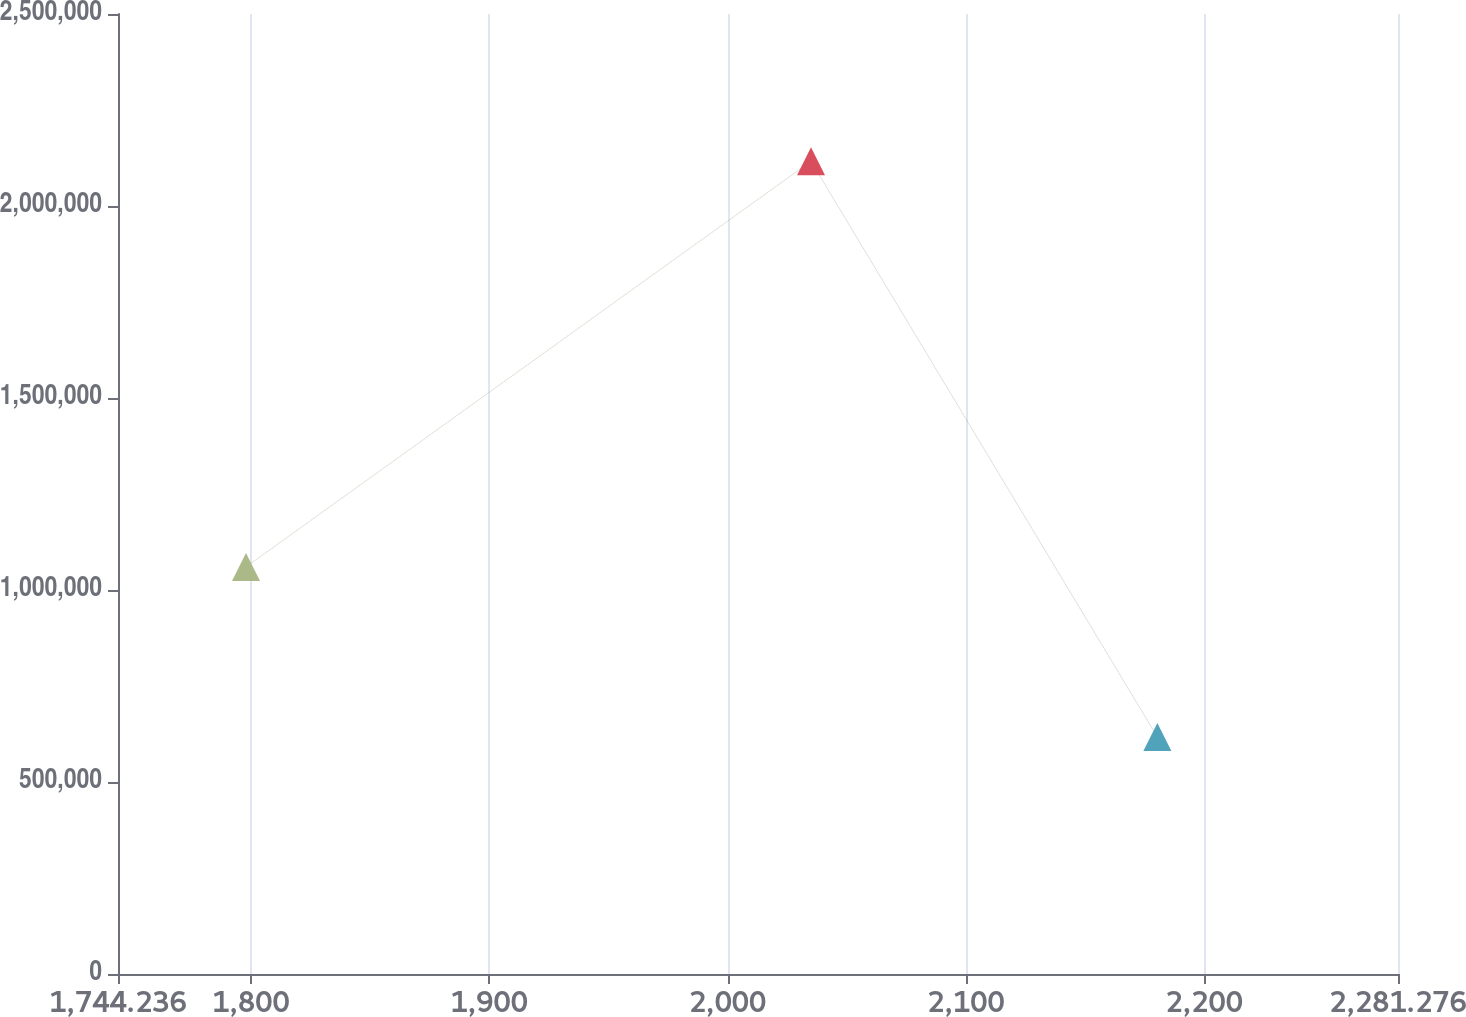Convert chart. <chart><loc_0><loc_0><loc_500><loc_500><line_chart><ecel><fcel>Unnamed: 1<nl><fcel>1797.94<fcel>1.06e+06<nl><fcel>2034.98<fcel>2.11642e+06<nl><fcel>2180.31<fcel>617233<nl><fcel>2334.98<fcel>1.57896e+06<nl></chart> 